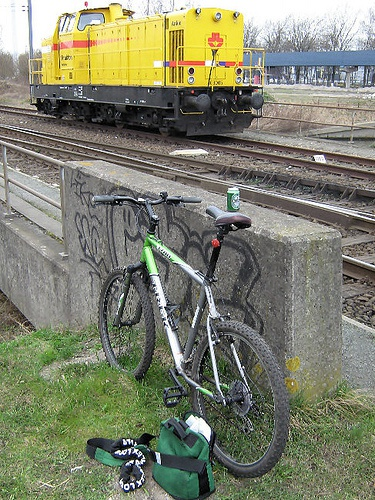Describe the objects in this image and their specific colors. I can see bicycle in white, gray, black, and darkgray tones, train in white, khaki, gold, and ivory tones, and handbag in white, black, teal, and gray tones in this image. 